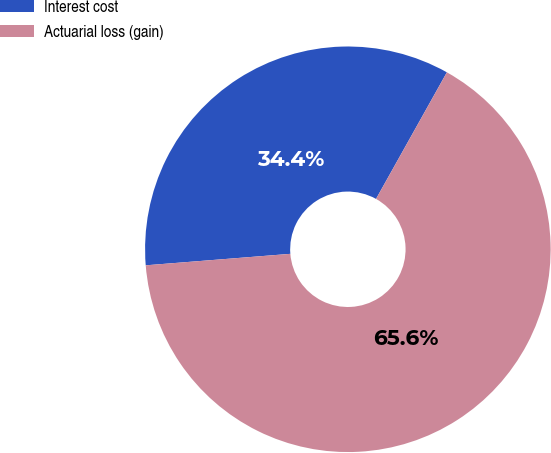Convert chart to OTSL. <chart><loc_0><loc_0><loc_500><loc_500><pie_chart><fcel>Interest cost<fcel>Actuarial loss (gain)<nl><fcel>34.38%<fcel>65.62%<nl></chart> 